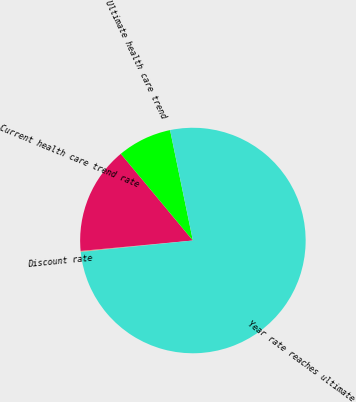Convert chart to OTSL. <chart><loc_0><loc_0><loc_500><loc_500><pie_chart><fcel>Discount rate<fcel>Current health care trend rate<fcel>Ultimate health care trend<fcel>Year rate reaches ultimate<nl><fcel>0.14%<fcel>15.44%<fcel>7.79%<fcel>76.63%<nl></chart> 